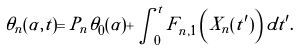Convert formula to latex. <formula><loc_0><loc_0><loc_500><loc_500>\tilde { \theta } _ { n } ( \alpha , t ) = P _ { n } \theta _ { 0 } ( \alpha ) + \int _ { 0 } ^ { t } F _ { n , 1 } \left ( X _ { n } ( t ^ { \prime } ) \right ) d t ^ { \prime } .</formula> 